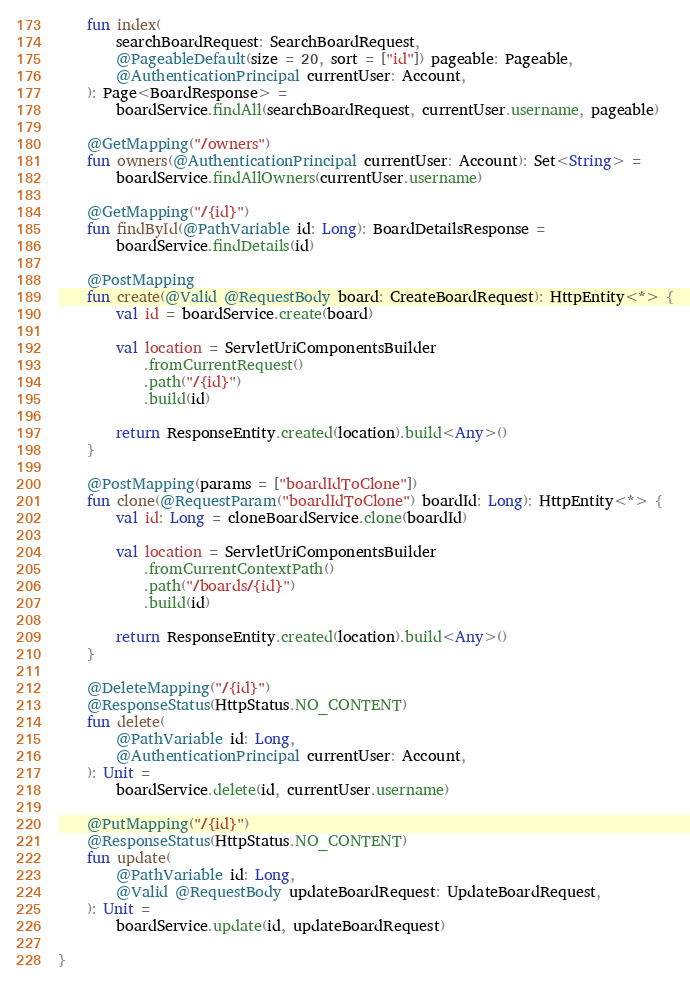<code> <loc_0><loc_0><loc_500><loc_500><_Kotlin_>    fun index(
        searchBoardRequest: SearchBoardRequest,
        @PageableDefault(size = 20, sort = ["id"]) pageable: Pageable,
        @AuthenticationPrincipal currentUser: Account,
    ): Page<BoardResponse> =
        boardService.findAll(searchBoardRequest, currentUser.username, pageable)

    @GetMapping("/owners")
    fun owners(@AuthenticationPrincipal currentUser: Account): Set<String> =
        boardService.findAllOwners(currentUser.username)

    @GetMapping("/{id}")
    fun findById(@PathVariable id: Long): BoardDetailsResponse =
        boardService.findDetails(id)

    @PostMapping
    fun create(@Valid @RequestBody board: CreateBoardRequest): HttpEntity<*> {
        val id = boardService.create(board)

        val location = ServletUriComponentsBuilder
            .fromCurrentRequest()
            .path("/{id}")
            .build(id)

        return ResponseEntity.created(location).build<Any>()
    }

    @PostMapping(params = ["boardIdToClone"])
    fun clone(@RequestParam("boardIdToClone") boardId: Long): HttpEntity<*> {
        val id: Long = cloneBoardService.clone(boardId)

        val location = ServletUriComponentsBuilder
            .fromCurrentContextPath()
            .path("/boards/{id}")
            .build(id)

        return ResponseEntity.created(location).build<Any>()
    }

    @DeleteMapping("/{id}")
    @ResponseStatus(HttpStatus.NO_CONTENT)
    fun delete(
        @PathVariable id: Long,
        @AuthenticationPrincipal currentUser: Account,
    ): Unit =
        boardService.delete(id, currentUser.username)

    @PutMapping("/{id}")
    @ResponseStatus(HttpStatus.NO_CONTENT)
    fun update(
        @PathVariable id: Long,
        @Valid @RequestBody updateBoardRequest: UpdateBoardRequest,
    ): Unit =
        boardService.update(id, updateBoardRequest)

}
</code> 